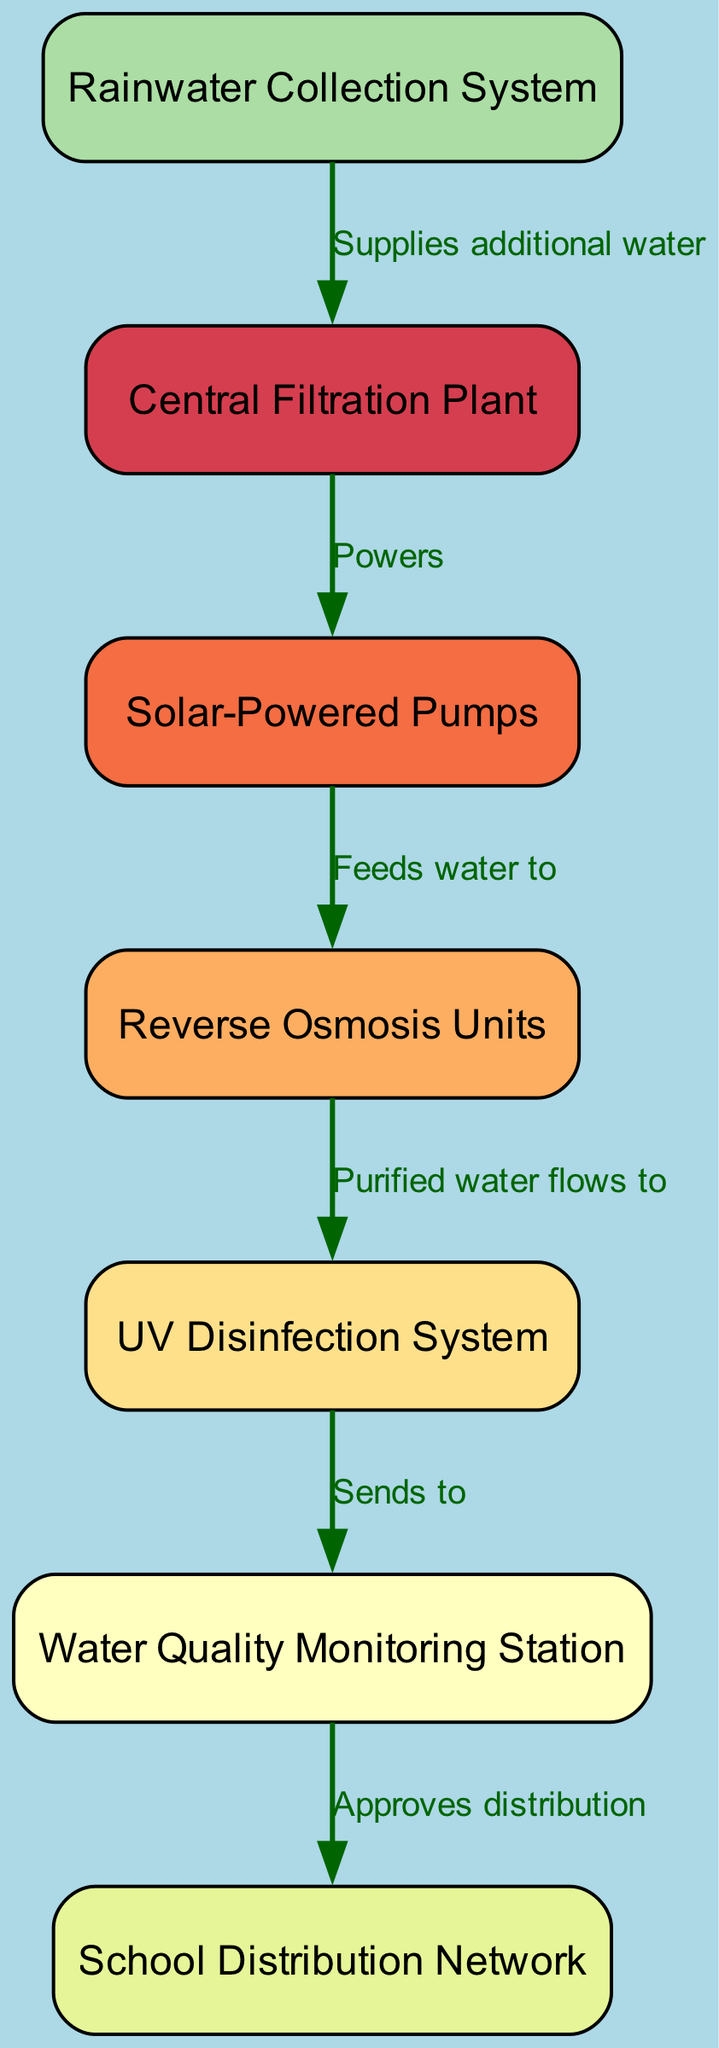What is the total number of nodes in the diagram? The diagram consists of seven labeled components or entities. Each of these entities is considered a node. Therefore, by counting the nodes listed in the data, I find a total of seven nodes.
Answer: 7 What component sends purified water? The Reverse Osmosis Units is the component where the purified water flows to the UV Disinfection System. Based on the direction of flow and connections shown in the diagram, this is the relevant node that sends out purified water.
Answer: Reverse Osmosis Units What is the role of the School Distribution Network? The School Distribution Network is responsible for distributing the approved purified water, as indicated by the connection from the Water Quality Monitoring Station to this node.
Answer: Approves distribution Which system supplies additional water to the Central Filtration Plant? The Rainwater Collection System supplies additional water to the Central Filtration Plant, as shown by the directed edge in the diagram connecting these two components.
Answer: Rainwater Collection System From which node does the water flow after being treated? After the water is treated by the UV Disinfection System, it flows to the Water Quality Monitoring Station, making this the immediate next destination in the sequence.
Answer: Water Quality Monitoring Station What type of pumps are used in the system? The system employs Solar-Powered Pumps, as indicated in the diagram which describes the power relationship between the Central Filtration Plant and these pumps.
Answer: Solar-Powered Pumps How many edges connect the nodes in the diagram? There are six directed edges in the diagram that represent relationships or flows of water between the nodes. By counting the relationships listed, we confirm there are six connections.
Answer: 6 What is the first step in the water purification process according to the diagram? The first step is the Solar-Powered Pumps feeding water into the Reverse Osmosis Units, as illustrated by the directed edge that connects these two components.
Answer: Solar-Powered Pumps Which component follows the Reverse Osmosis Units in the flow? The UV Disinfection System follows the Reverse Osmosis Units in the water treatment process. This is indicated by the directed edge flowing from the Reverse Osmosis Units to the UV Disinfection System.
Answer: UV Disinfection System 